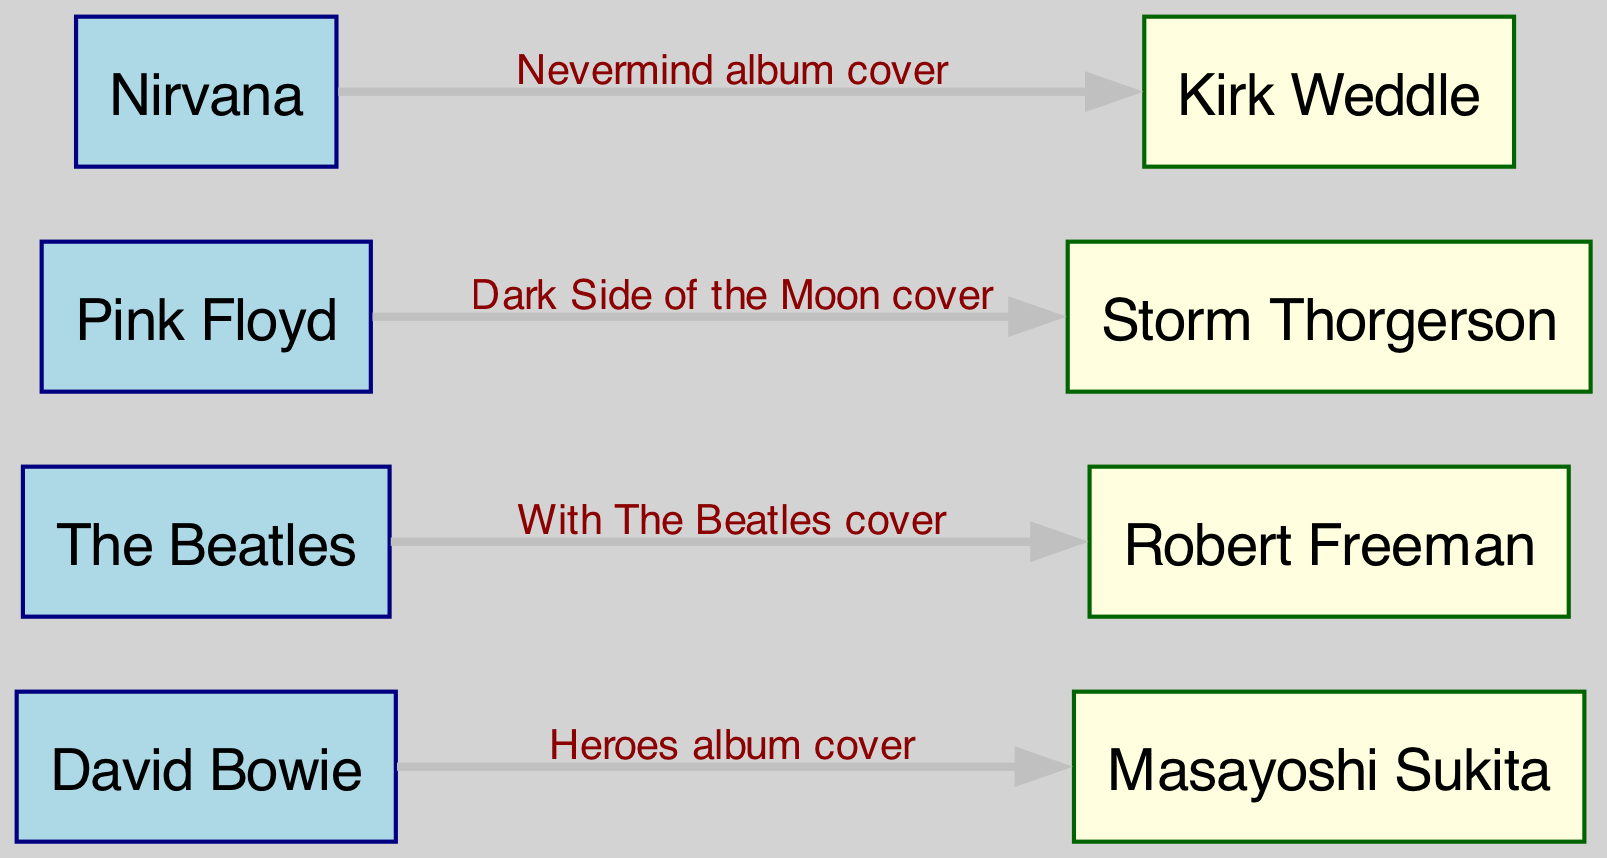What are the total number of musicians in the diagram? There are 4 musician nodes depicted in the diagram: David Bowie, The Beatles, Pink Floyd, and Nirvana.
Answer: 4 Who is the photographer associated with the "Nevermind album cover"? The edge connecting Nirvana (the musician) to Kirk Weddle (the photographer) indicates that Kirk Weddle is the associated photographer for the "Nevermind album cover".
Answer: Kirk Weddle What is the title of the album cover associated with David Bowie? The edge labeled "Heroes album cover" connects David Bowie to Masayoshi Sukita, indicating that this is the title of the album cover he is associated with.
Answer: Heroes album cover Which musician is linked to Robert Freeman? The edge that leads from The Beatles to Robert Freeman shows that Robert Freeman is connected to The Beatles, which identifies the musician associated with him.
Answer: The Beatles How many connections (edges) are there in total between musicians and photographers? By counting the connections (edges), which are the labels between nodes, there are 4 connections illustrated in the diagram: one for each musician-photographer pair.
Answer: 4 Which musician's album cover is associated with Storm Thorgerson? The edge between Pink Floyd and Storm Thorgerson indicates that Storm Thorgerson is the photographer for Pink Floyd's album cover, specifically the "Dark Side of the Moon cover".
Answer: Pink Floyd 